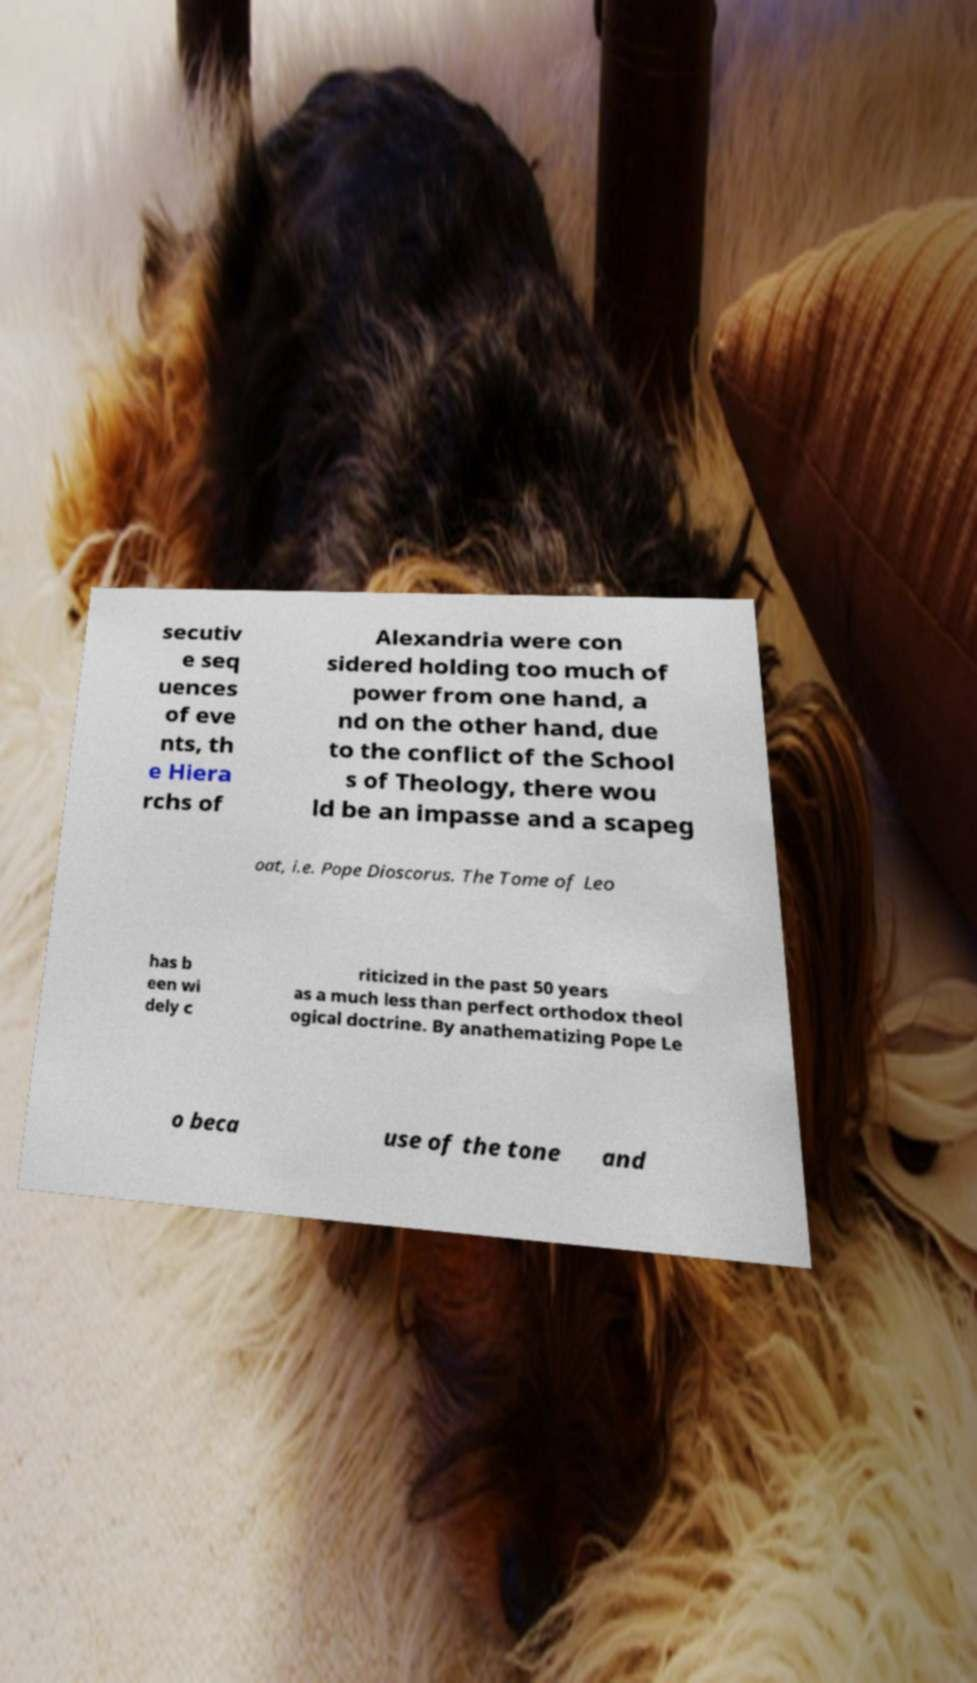I need the written content from this picture converted into text. Can you do that? secutiv e seq uences of eve nts, th e Hiera rchs of Alexandria were con sidered holding too much of power from one hand, a nd on the other hand, due to the conflict of the School s of Theology, there wou ld be an impasse and a scapeg oat, i.e. Pope Dioscorus. The Tome of Leo has b een wi dely c riticized in the past 50 years as a much less than perfect orthodox theol ogical doctrine. By anathematizing Pope Le o beca use of the tone and 